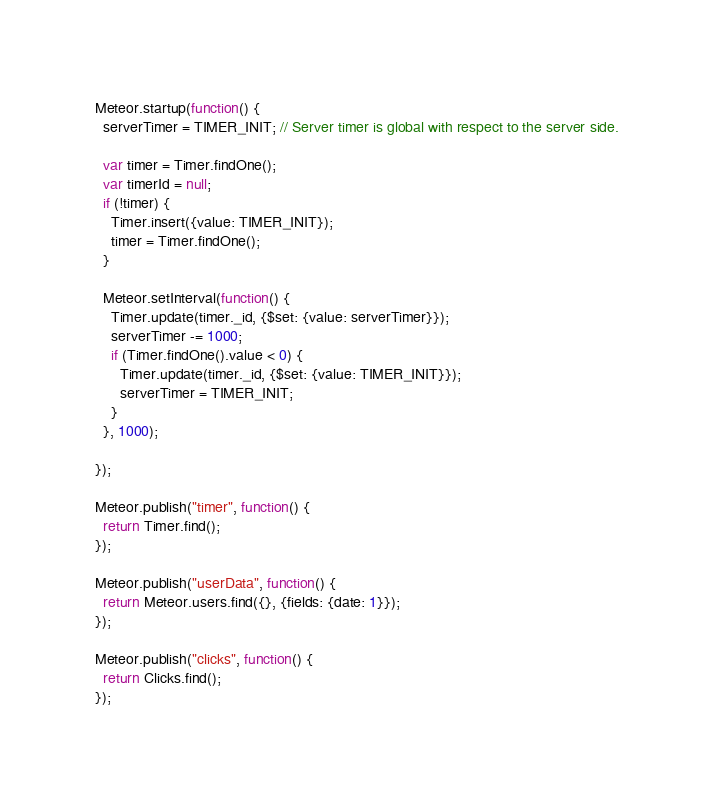<code> <loc_0><loc_0><loc_500><loc_500><_JavaScript_>Meteor.startup(function() {
  serverTimer = TIMER_INIT; // Server timer is global with respect to the server side.

  var timer = Timer.findOne();
  var timerId = null;
  if (!timer) {
    Timer.insert({value: TIMER_INIT});
    timer = Timer.findOne();
  }

  Meteor.setInterval(function() {
    Timer.update(timer._id, {$set: {value: serverTimer}});
    serverTimer -= 1000;
    if (Timer.findOne().value < 0) {
      Timer.update(timer._id, {$set: {value: TIMER_INIT}});
      serverTimer = TIMER_INIT;
    }
  }, 1000);

});

Meteor.publish("timer", function() {
  return Timer.find();
});

Meteor.publish("userData", function() {
  return Meteor.users.find({}, {fields: {date: 1}});
});

Meteor.publish("clicks", function() {
  return Clicks.find();
});
</code> 